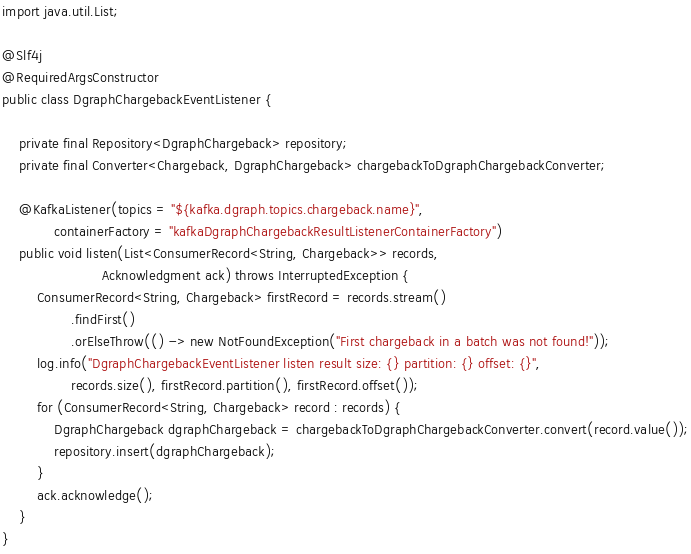<code> <loc_0><loc_0><loc_500><loc_500><_Java_>
import java.util.List;

@Slf4j
@RequiredArgsConstructor
public class DgraphChargebackEventListener {

    private final Repository<DgraphChargeback> repository;
    private final Converter<Chargeback, DgraphChargeback> chargebackToDgraphChargebackConverter;

    @KafkaListener(topics = "${kafka.dgraph.topics.chargeback.name}",
            containerFactory = "kafkaDgraphChargebackResultListenerContainerFactory")
    public void listen(List<ConsumerRecord<String, Chargeback>> records,
                       Acknowledgment ack) throws InterruptedException {
        ConsumerRecord<String, Chargeback> firstRecord = records.stream()
                .findFirst()
                .orElseThrow(() -> new NotFoundException("First chargeback in a batch was not found!"));
        log.info("DgraphChargebackEventListener listen result size: {} partition: {} offset: {}",
                records.size(), firstRecord.partition(), firstRecord.offset());
        for (ConsumerRecord<String, Chargeback> record : records) {
            DgraphChargeback dgraphChargeback = chargebackToDgraphChargebackConverter.convert(record.value());
            repository.insert(dgraphChargeback);
        }
        ack.acknowledge();
    }
}
</code> 